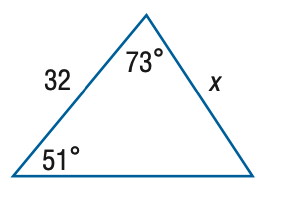Answer the mathemtical geometry problem and directly provide the correct option letter.
Question: Find x. Round side measure to the nearest tenth.
Choices: A: 26.0 B: 30.0 C: 34.1 D: 39.4 B 